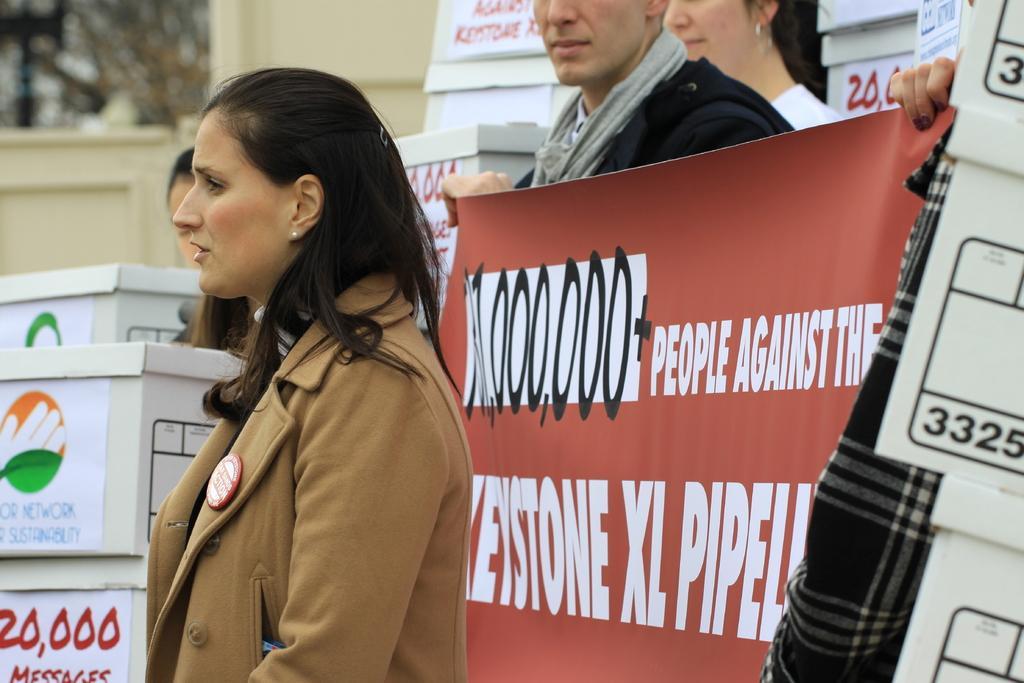Can you describe this image briefly? In this image I can see few people are wearing different color dresses. I can see few boxes and few stickers are attached to it. I can see two people are holding the banner. 